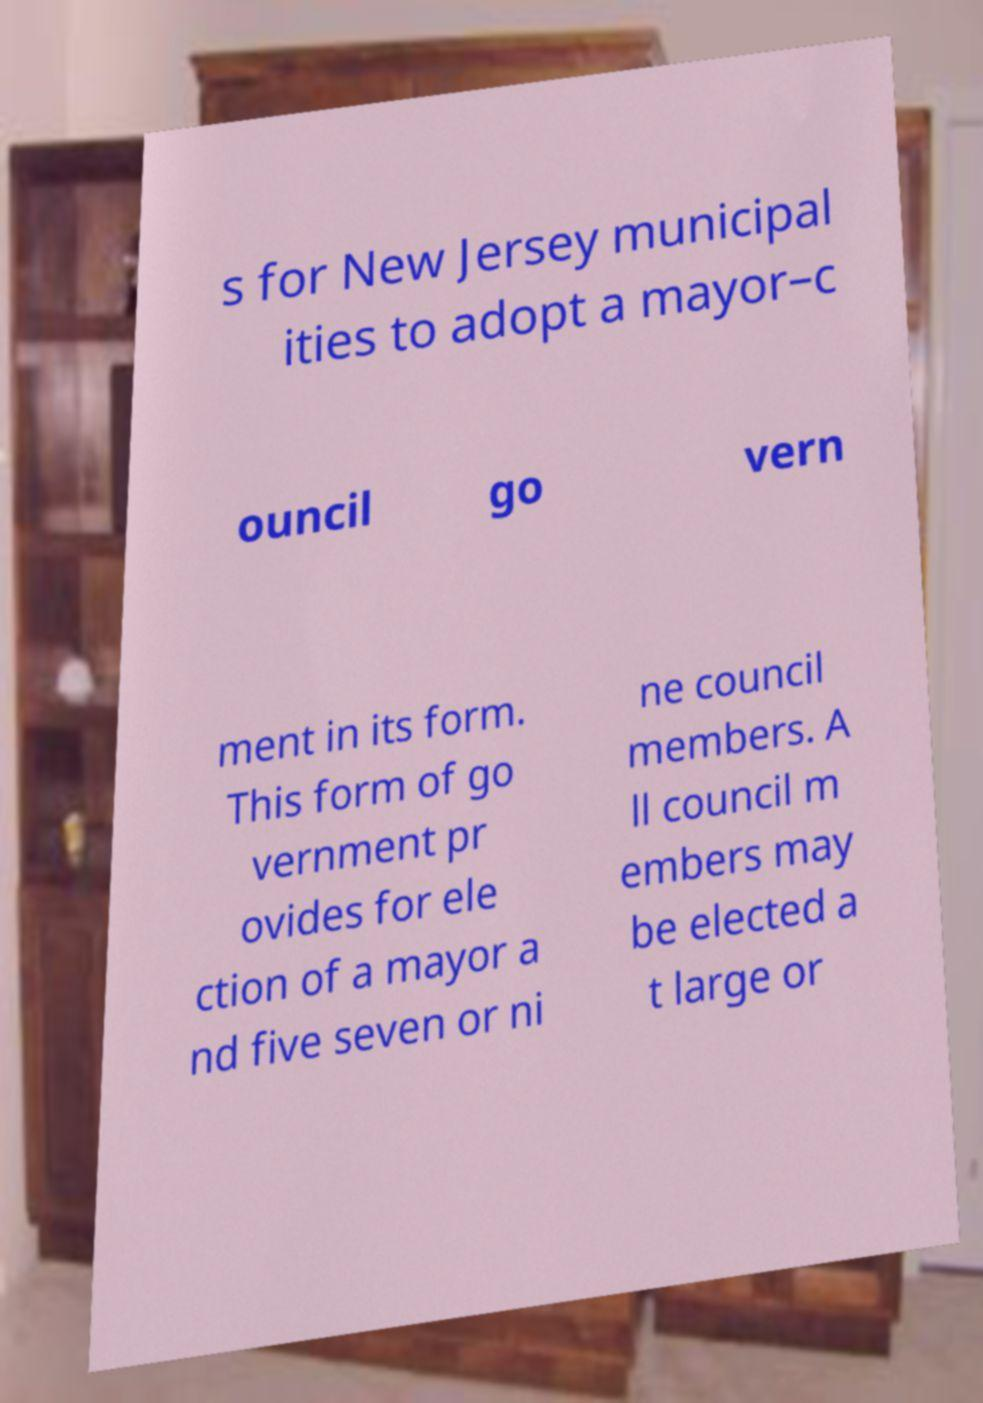Please read and relay the text visible in this image. What does it say? s for New Jersey municipal ities to adopt a mayor–c ouncil go vern ment in its form. This form of go vernment pr ovides for ele ction of a mayor a nd five seven or ni ne council members. A ll council m embers may be elected a t large or 